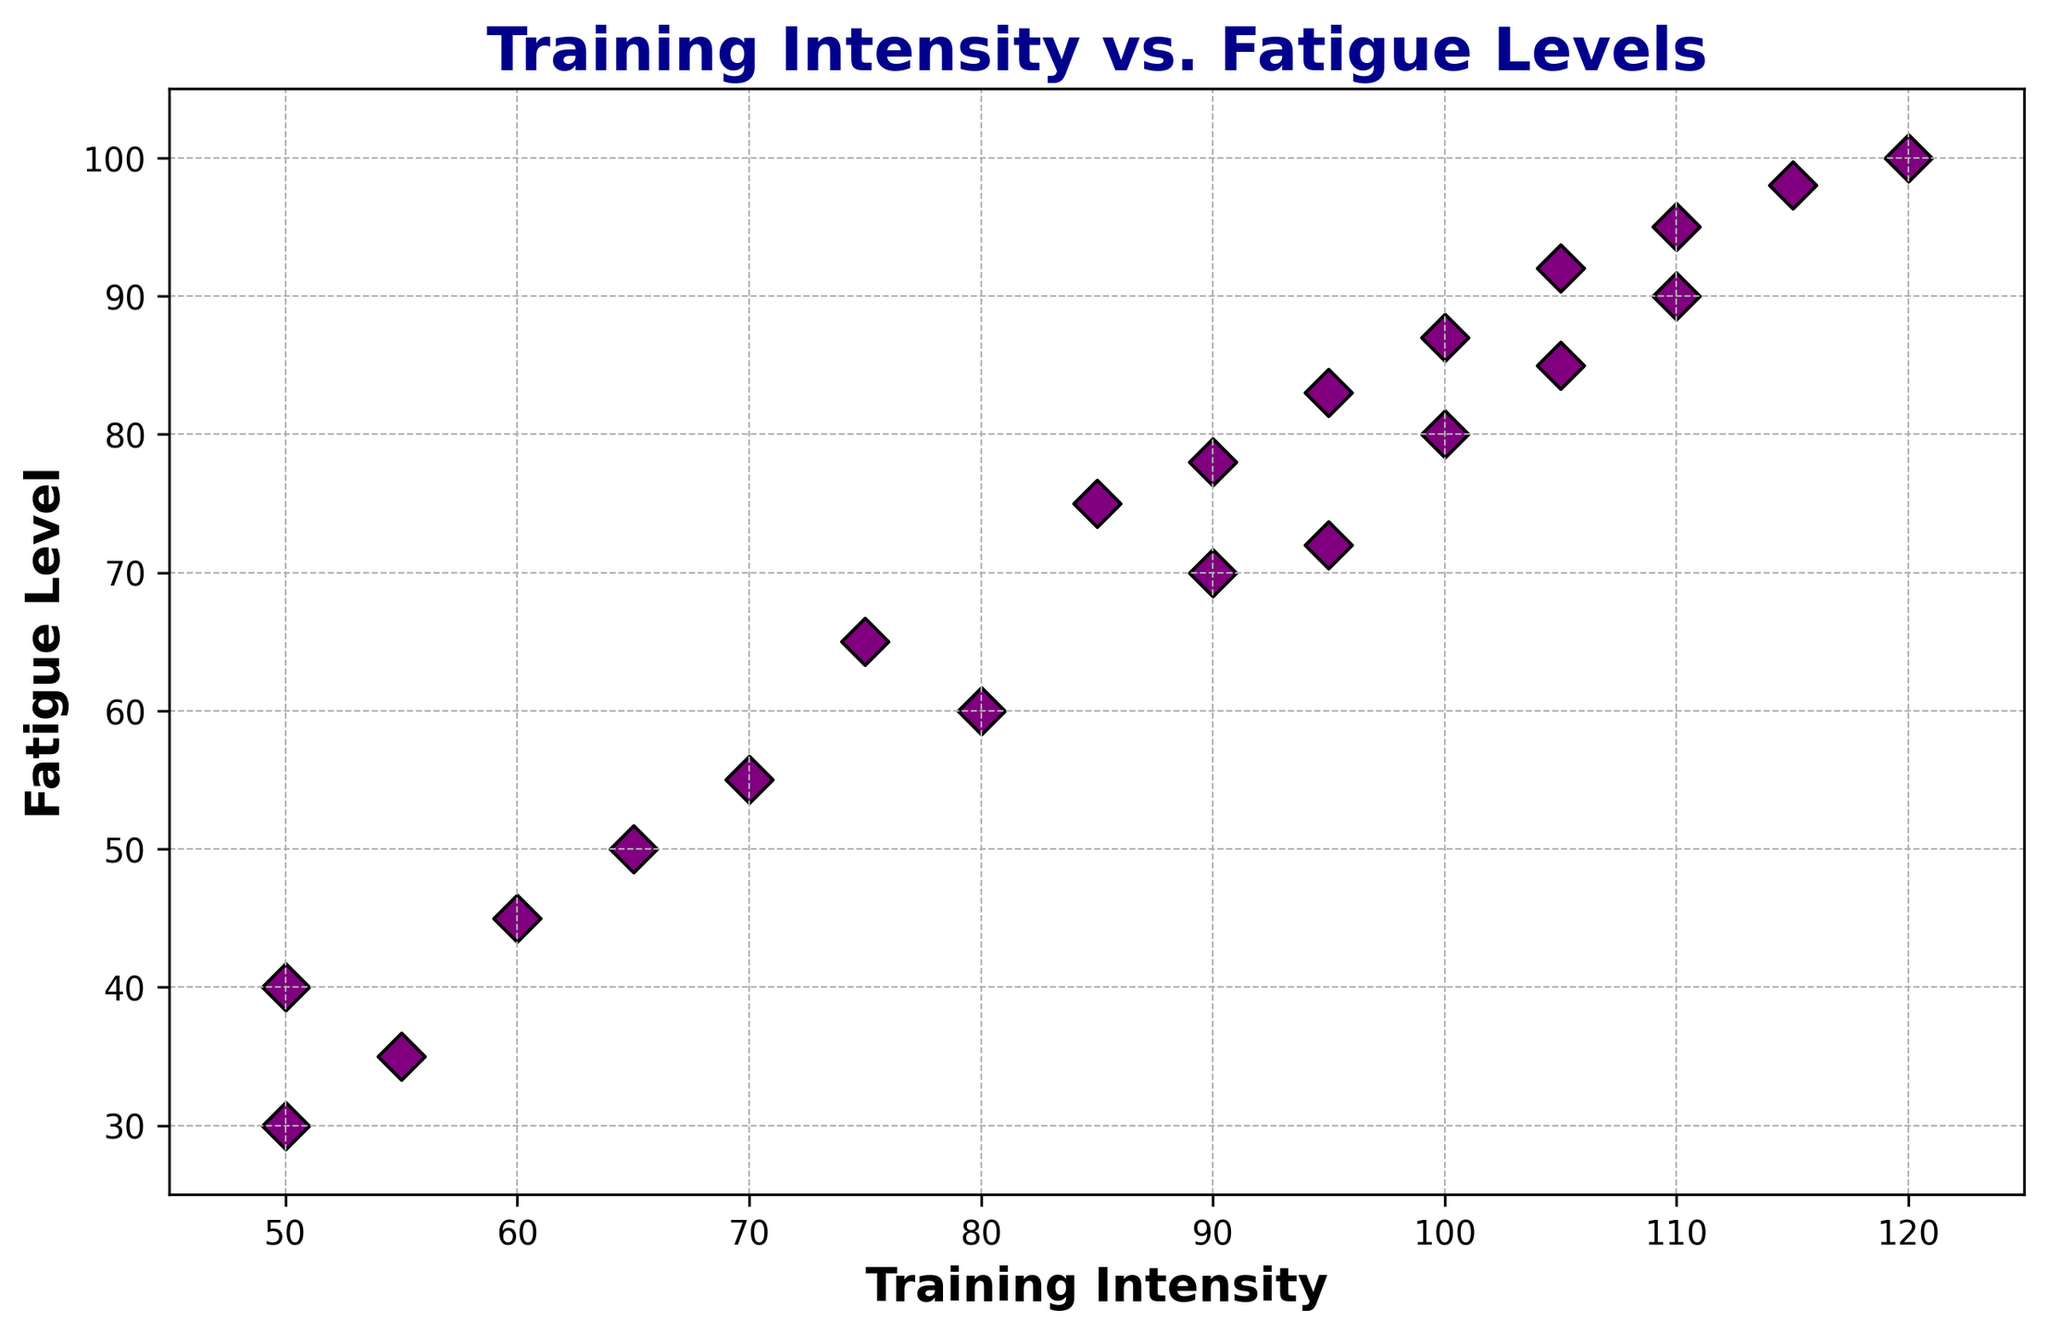What's the highest level of fatigue observed in the figure? The highest fatigue level can be seen on the y-axis of the scatter plot. By examining the furthest data point vertically, the maximum fatigue level is indicated as 100.
Answer: 100 How many data points have a training intensity greater than 100? To determine this, count the number of data points where the x-coordinate (training intensity) is greater than 100. There are 4 such points.
Answer: 4 Is there a training intensity with multiple corresponding fatigue levels? If yes, what is it? To find this, look for vertical alignments where multiple points share the same x-value. The training intensity of 50 has two different fatigue levels at 30 and 40.
Answer: Yes, 50 Which training intensity corresponds to the median fatigue level? To determine the median fatigue level, list all fatigue levels in order and find the middle value. The middle values are between 72 and 75, both corresponding to a training intensity of 90.
Answer: 90 What is the average fatigue level for training intensities under 70? Identify the fatigue levels for data points with training intensities less than 70 (40, 45, 30, 35, 50, 55). Add these values and divide by the number of points: (40+45+30+35+50+55) / 6 = 42.5.
Answer: 42.5 Are there any data points where the fatigue level equals the training intensity? To find this, look for any points where the x-coordinate and y-coordinate are equal. There are no such points in the plot.
Answer: No Which data point shows the smallest difference between training intensity and fatigue level? Calculate the absolute differences for each data point. The smallest difference is 5, seen with training intensities 50 and fatigue level 45 and with training intensity 95 and fatigue level 90.
Answer: (50, 45) or (95, 90) How does the spread of training intensities and fatigue levels visually appear in the scatter plot? The spread can be examined based on the dispersion of points. The points form an upward trend indicating a strong positive correlation, suggesting that as training intensity increases, fatigue levels also increase prominently.
Answer: Strong positive correlation Between training intensities 90 and 100, how much does the fatigue level increase? Identify the fatigue levels corresponding to training intensities of 90 (70, 78) and 100 (80, 87). Calculate the increase: (80-70), (87-78), which are 10 and 9 for each pair.
Answer: 9 to 10 Which color is used for the data points in the scatter plot? Observing the scatter plot reveals that all data points are colored in purple.
Answer: Purple 